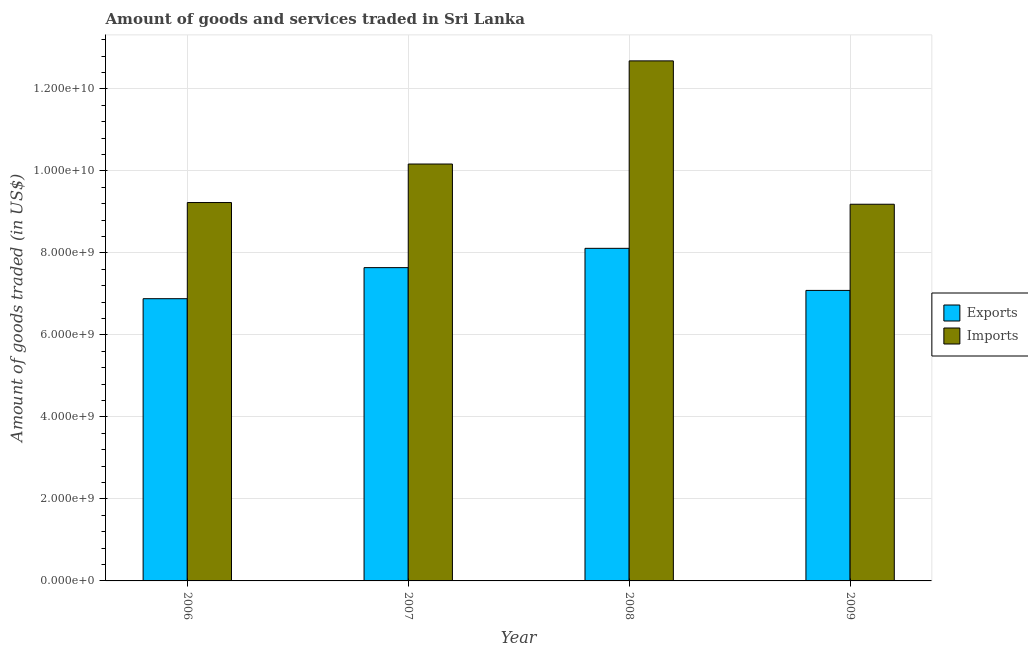How many bars are there on the 1st tick from the left?
Provide a succinct answer. 2. How many bars are there on the 2nd tick from the right?
Make the answer very short. 2. What is the label of the 2nd group of bars from the left?
Offer a terse response. 2007. In how many cases, is the number of bars for a given year not equal to the number of legend labels?
Your answer should be very brief. 0. What is the amount of goods exported in 2008?
Your answer should be very brief. 8.11e+09. Across all years, what is the maximum amount of goods exported?
Your response must be concise. 8.11e+09. Across all years, what is the minimum amount of goods exported?
Your answer should be very brief. 6.88e+09. In which year was the amount of goods imported minimum?
Make the answer very short. 2009. What is the total amount of goods imported in the graph?
Your answer should be very brief. 4.13e+1. What is the difference between the amount of goods exported in 2006 and that in 2007?
Make the answer very short. -7.57e+08. What is the difference between the amount of goods imported in 2006 and the amount of goods exported in 2007?
Offer a terse response. -9.39e+08. What is the average amount of goods imported per year?
Offer a very short reply. 1.03e+1. In the year 2006, what is the difference between the amount of goods imported and amount of goods exported?
Offer a terse response. 0. In how many years, is the amount of goods exported greater than 7200000000 US$?
Your response must be concise. 2. What is the ratio of the amount of goods exported in 2006 to that in 2009?
Make the answer very short. 0.97. Is the difference between the amount of goods exported in 2007 and 2009 greater than the difference between the amount of goods imported in 2007 and 2009?
Make the answer very short. No. What is the difference between the highest and the second highest amount of goods imported?
Make the answer very short. 2.52e+09. What is the difference between the highest and the lowest amount of goods imported?
Offer a very short reply. 3.50e+09. Is the sum of the amount of goods imported in 2007 and 2009 greater than the maximum amount of goods exported across all years?
Provide a succinct answer. Yes. What does the 1st bar from the left in 2007 represents?
Your answer should be compact. Exports. What does the 1st bar from the right in 2009 represents?
Provide a succinct answer. Imports. How many bars are there?
Offer a terse response. 8. How many years are there in the graph?
Offer a very short reply. 4. What is the difference between two consecutive major ticks on the Y-axis?
Your answer should be compact. 2.00e+09. Are the values on the major ticks of Y-axis written in scientific E-notation?
Make the answer very short. Yes. Does the graph contain grids?
Your response must be concise. Yes. How many legend labels are there?
Offer a terse response. 2. How are the legend labels stacked?
Offer a terse response. Vertical. What is the title of the graph?
Keep it short and to the point. Amount of goods and services traded in Sri Lanka. What is the label or title of the X-axis?
Provide a succinct answer. Year. What is the label or title of the Y-axis?
Offer a terse response. Amount of goods traded (in US$). What is the Amount of goods traded (in US$) of Exports in 2006?
Provide a short and direct response. 6.88e+09. What is the Amount of goods traded (in US$) of Imports in 2006?
Keep it short and to the point. 9.23e+09. What is the Amount of goods traded (in US$) in Exports in 2007?
Give a very brief answer. 7.64e+09. What is the Amount of goods traded (in US$) in Imports in 2007?
Your answer should be compact. 1.02e+1. What is the Amount of goods traded (in US$) of Exports in 2008?
Offer a terse response. 8.11e+09. What is the Amount of goods traded (in US$) of Imports in 2008?
Offer a terse response. 1.27e+1. What is the Amount of goods traded (in US$) of Exports in 2009?
Your answer should be very brief. 7.08e+09. What is the Amount of goods traded (in US$) of Imports in 2009?
Ensure brevity in your answer.  9.19e+09. Across all years, what is the maximum Amount of goods traded (in US$) of Exports?
Your answer should be compact. 8.11e+09. Across all years, what is the maximum Amount of goods traded (in US$) in Imports?
Your answer should be compact. 1.27e+1. Across all years, what is the minimum Amount of goods traded (in US$) of Exports?
Your response must be concise. 6.88e+09. Across all years, what is the minimum Amount of goods traded (in US$) of Imports?
Offer a very short reply. 9.19e+09. What is the total Amount of goods traded (in US$) in Exports in the graph?
Offer a terse response. 2.97e+1. What is the total Amount of goods traded (in US$) of Imports in the graph?
Your answer should be compact. 4.13e+1. What is the difference between the Amount of goods traded (in US$) in Exports in 2006 and that in 2007?
Keep it short and to the point. -7.57e+08. What is the difference between the Amount of goods traded (in US$) of Imports in 2006 and that in 2007?
Keep it short and to the point. -9.39e+08. What is the difference between the Amount of goods traded (in US$) in Exports in 2006 and that in 2008?
Your answer should be compact. -1.23e+09. What is the difference between the Amount of goods traded (in US$) in Imports in 2006 and that in 2008?
Make the answer very short. -3.45e+09. What is the difference between the Amount of goods traded (in US$) of Exports in 2006 and that in 2009?
Keep it short and to the point. -2.02e+08. What is the difference between the Amount of goods traded (in US$) of Imports in 2006 and that in 2009?
Offer a terse response. 4.17e+07. What is the difference between the Amount of goods traded (in US$) of Exports in 2007 and that in 2008?
Offer a terse response. -4.71e+08. What is the difference between the Amount of goods traded (in US$) of Imports in 2007 and that in 2008?
Provide a short and direct response. -2.52e+09. What is the difference between the Amount of goods traded (in US$) of Exports in 2007 and that in 2009?
Keep it short and to the point. 5.55e+08. What is the difference between the Amount of goods traded (in US$) in Imports in 2007 and that in 2009?
Make the answer very short. 9.81e+08. What is the difference between the Amount of goods traded (in US$) in Exports in 2008 and that in 2009?
Offer a terse response. 1.03e+09. What is the difference between the Amount of goods traded (in US$) of Imports in 2008 and that in 2009?
Your answer should be compact. 3.50e+09. What is the difference between the Amount of goods traded (in US$) of Exports in 2006 and the Amount of goods traded (in US$) of Imports in 2007?
Give a very brief answer. -3.28e+09. What is the difference between the Amount of goods traded (in US$) in Exports in 2006 and the Amount of goods traded (in US$) in Imports in 2008?
Your response must be concise. -5.80e+09. What is the difference between the Amount of goods traded (in US$) in Exports in 2006 and the Amount of goods traded (in US$) in Imports in 2009?
Offer a very short reply. -2.30e+09. What is the difference between the Amount of goods traded (in US$) in Exports in 2007 and the Amount of goods traded (in US$) in Imports in 2008?
Your answer should be compact. -5.04e+09. What is the difference between the Amount of goods traded (in US$) in Exports in 2007 and the Amount of goods traded (in US$) in Imports in 2009?
Your answer should be very brief. -1.55e+09. What is the difference between the Amount of goods traded (in US$) of Exports in 2008 and the Amount of goods traded (in US$) of Imports in 2009?
Give a very brief answer. -1.08e+09. What is the average Amount of goods traded (in US$) of Exports per year?
Ensure brevity in your answer.  7.43e+09. What is the average Amount of goods traded (in US$) in Imports per year?
Offer a terse response. 1.03e+1. In the year 2006, what is the difference between the Amount of goods traded (in US$) in Exports and Amount of goods traded (in US$) in Imports?
Provide a short and direct response. -2.35e+09. In the year 2007, what is the difference between the Amount of goods traded (in US$) of Exports and Amount of goods traded (in US$) of Imports?
Provide a succinct answer. -2.53e+09. In the year 2008, what is the difference between the Amount of goods traded (in US$) of Exports and Amount of goods traded (in US$) of Imports?
Offer a terse response. -4.57e+09. In the year 2009, what is the difference between the Amount of goods traded (in US$) in Exports and Amount of goods traded (in US$) in Imports?
Your answer should be very brief. -2.10e+09. What is the ratio of the Amount of goods traded (in US$) in Exports in 2006 to that in 2007?
Ensure brevity in your answer.  0.9. What is the ratio of the Amount of goods traded (in US$) of Imports in 2006 to that in 2007?
Offer a terse response. 0.91. What is the ratio of the Amount of goods traded (in US$) of Exports in 2006 to that in 2008?
Your answer should be compact. 0.85. What is the ratio of the Amount of goods traded (in US$) of Imports in 2006 to that in 2008?
Give a very brief answer. 0.73. What is the ratio of the Amount of goods traded (in US$) of Exports in 2006 to that in 2009?
Your response must be concise. 0.97. What is the ratio of the Amount of goods traded (in US$) of Exports in 2007 to that in 2008?
Offer a very short reply. 0.94. What is the ratio of the Amount of goods traded (in US$) in Imports in 2007 to that in 2008?
Ensure brevity in your answer.  0.8. What is the ratio of the Amount of goods traded (in US$) in Exports in 2007 to that in 2009?
Offer a very short reply. 1.08. What is the ratio of the Amount of goods traded (in US$) of Imports in 2007 to that in 2009?
Your answer should be very brief. 1.11. What is the ratio of the Amount of goods traded (in US$) in Exports in 2008 to that in 2009?
Your answer should be very brief. 1.14. What is the ratio of the Amount of goods traded (in US$) in Imports in 2008 to that in 2009?
Offer a very short reply. 1.38. What is the difference between the highest and the second highest Amount of goods traded (in US$) in Exports?
Provide a succinct answer. 4.71e+08. What is the difference between the highest and the second highest Amount of goods traded (in US$) in Imports?
Keep it short and to the point. 2.52e+09. What is the difference between the highest and the lowest Amount of goods traded (in US$) in Exports?
Give a very brief answer. 1.23e+09. What is the difference between the highest and the lowest Amount of goods traded (in US$) of Imports?
Ensure brevity in your answer.  3.50e+09. 